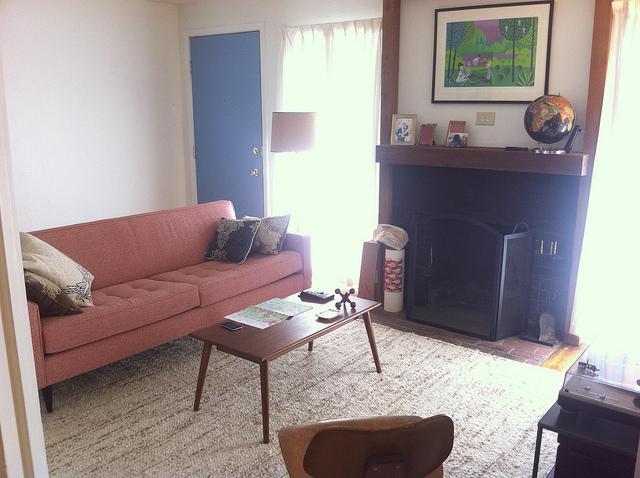Is the furniture made from leather?
Give a very brief answer. No. Is there an iPhone on the table?
Short answer required. Yes. Does the chair have a cushion?
Write a very short answer. No. Are there any people in the room?
Quick response, please. No. 